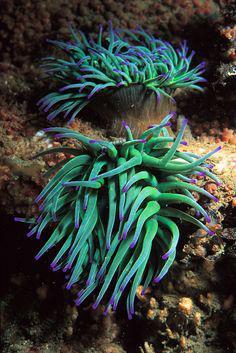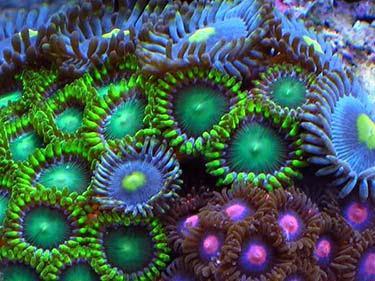The first image is the image on the left, the second image is the image on the right. Analyze the images presented: Is the assertion "At least one of the images contains an orange and white fish." valid? Answer yes or no. No. The first image is the image on the left, the second image is the image on the right. For the images displayed, is the sentence "Striped clownfish are swimming in one image of an anemone." factually correct? Answer yes or no. No. 